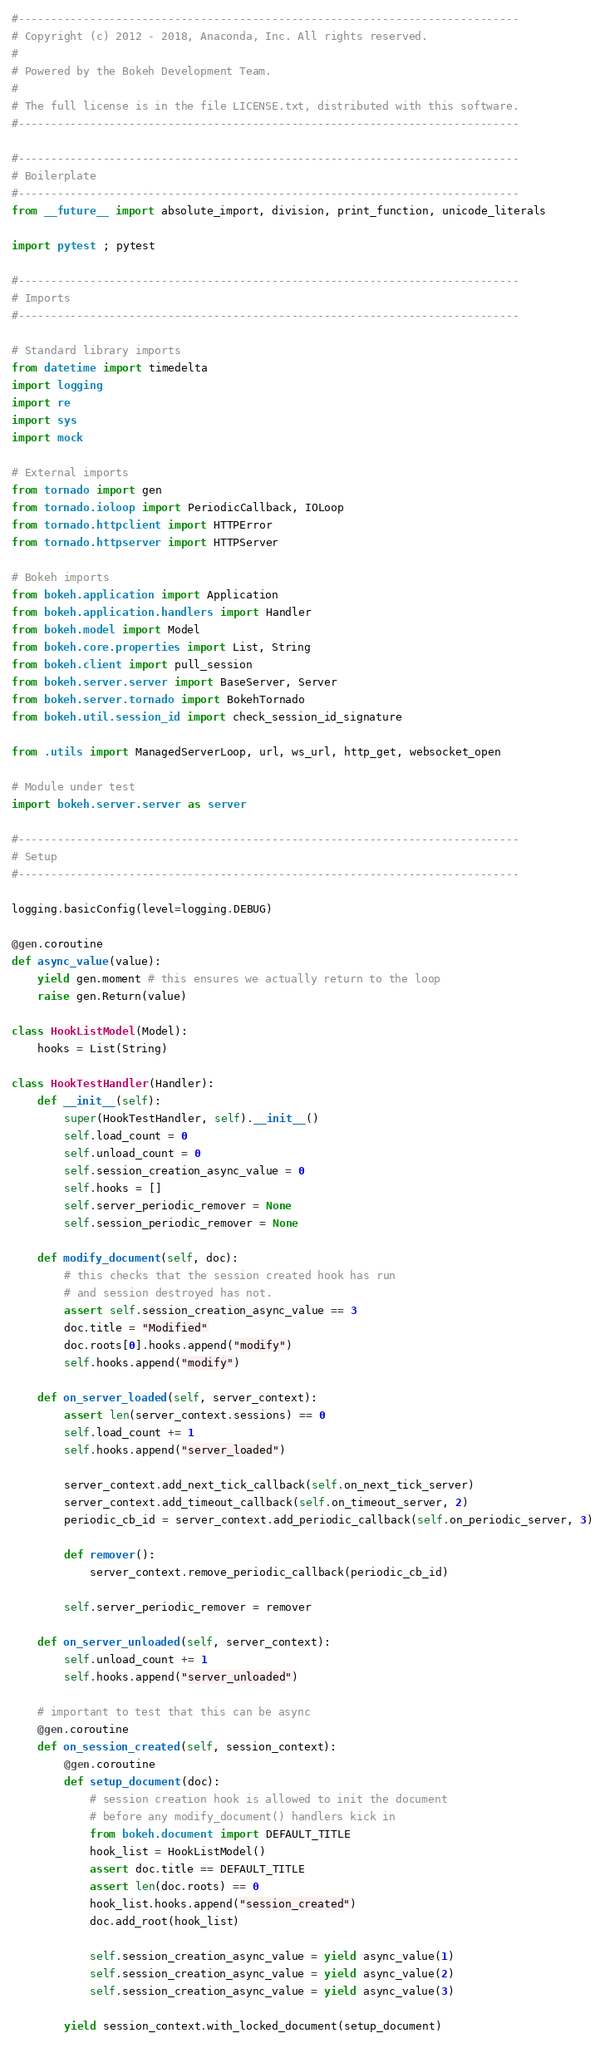<code> <loc_0><loc_0><loc_500><loc_500><_Python_>#-----------------------------------------------------------------------------
# Copyright (c) 2012 - 2018, Anaconda, Inc. All rights reserved.
#
# Powered by the Bokeh Development Team.
#
# The full license is in the file LICENSE.txt, distributed with this software.
#-----------------------------------------------------------------------------

#-----------------------------------------------------------------------------
# Boilerplate
#-----------------------------------------------------------------------------
from __future__ import absolute_import, division, print_function, unicode_literals

import pytest ; pytest

#-----------------------------------------------------------------------------
# Imports
#-----------------------------------------------------------------------------

# Standard library imports
from datetime import timedelta
import logging
import re
import sys
import mock

# External imports
from tornado import gen
from tornado.ioloop import PeriodicCallback, IOLoop
from tornado.httpclient import HTTPError
from tornado.httpserver import HTTPServer

# Bokeh imports
from bokeh.application import Application
from bokeh.application.handlers import Handler
from bokeh.model import Model
from bokeh.core.properties import List, String
from bokeh.client import pull_session
from bokeh.server.server import BaseServer, Server
from bokeh.server.tornado import BokehTornado
from bokeh.util.session_id import check_session_id_signature

from .utils import ManagedServerLoop, url, ws_url, http_get, websocket_open

# Module under test
import bokeh.server.server as server

#-----------------------------------------------------------------------------
# Setup
#-----------------------------------------------------------------------------

logging.basicConfig(level=logging.DEBUG)

@gen.coroutine
def async_value(value):
    yield gen.moment # this ensures we actually return to the loop
    raise gen.Return(value)

class HookListModel(Model):
    hooks = List(String)

class HookTestHandler(Handler):
    def __init__(self):
        super(HookTestHandler, self).__init__()
        self.load_count = 0
        self.unload_count = 0
        self.session_creation_async_value = 0
        self.hooks = []
        self.server_periodic_remover = None
        self.session_periodic_remover = None

    def modify_document(self, doc):
        # this checks that the session created hook has run
        # and session destroyed has not.
        assert self.session_creation_async_value == 3
        doc.title = "Modified"
        doc.roots[0].hooks.append("modify")
        self.hooks.append("modify")

    def on_server_loaded(self, server_context):
        assert len(server_context.sessions) == 0
        self.load_count += 1
        self.hooks.append("server_loaded")

        server_context.add_next_tick_callback(self.on_next_tick_server)
        server_context.add_timeout_callback(self.on_timeout_server, 2)
        periodic_cb_id = server_context.add_periodic_callback(self.on_periodic_server, 3)

        def remover():
            server_context.remove_periodic_callback(periodic_cb_id)

        self.server_periodic_remover = remover

    def on_server_unloaded(self, server_context):
        self.unload_count += 1
        self.hooks.append("server_unloaded")

    # important to test that this can be async
    @gen.coroutine
    def on_session_created(self, session_context):
        @gen.coroutine
        def setup_document(doc):
            # session creation hook is allowed to init the document
            # before any modify_document() handlers kick in
            from bokeh.document import DEFAULT_TITLE
            hook_list = HookListModel()
            assert doc.title == DEFAULT_TITLE
            assert len(doc.roots) == 0
            hook_list.hooks.append("session_created")
            doc.add_root(hook_list)

            self.session_creation_async_value = yield async_value(1)
            self.session_creation_async_value = yield async_value(2)
            self.session_creation_async_value = yield async_value(3)

        yield session_context.with_locked_document(setup_document)
</code> 